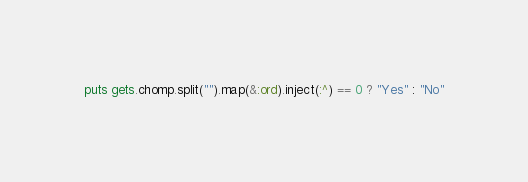<code> <loc_0><loc_0><loc_500><loc_500><_Ruby_>puts gets.chomp.split("").map(&:ord).inject(:^) == 0 ? "Yes" : "No"</code> 